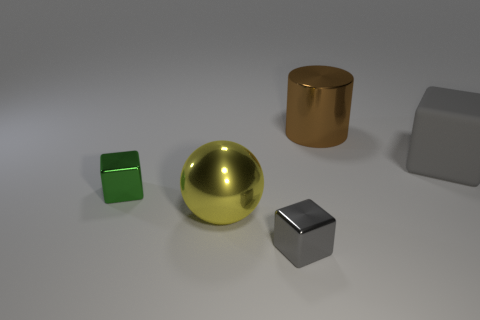Subtract all gray cubes. How many were subtracted if there are1gray cubes left? 1 Add 3 gray metallic objects. How many objects exist? 8 Subtract all small shiny blocks. How many blocks are left? 1 Subtract all gray cubes. How many cubes are left? 1 Subtract 0 gray cylinders. How many objects are left? 5 Subtract all spheres. How many objects are left? 4 Subtract 1 cubes. How many cubes are left? 2 Subtract all cyan cubes. Subtract all red cylinders. How many cubes are left? 3 Subtract all red balls. How many gray cylinders are left? 0 Subtract all brown metallic cylinders. Subtract all small yellow metal balls. How many objects are left? 4 